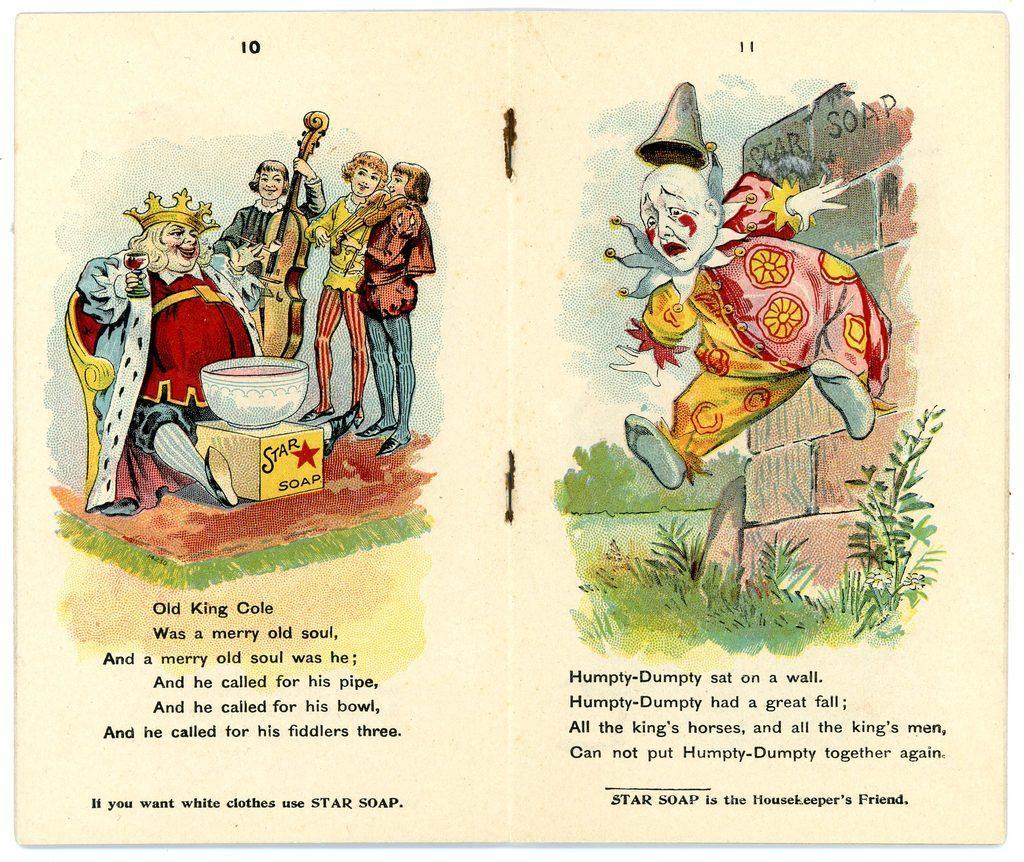Describe this image in one or two sentences. In the center of the image there is a book and we can see people in the center. There is a bowl placed on the stand. On the right there is a wall and we can see plants. At the bottom there is text. 